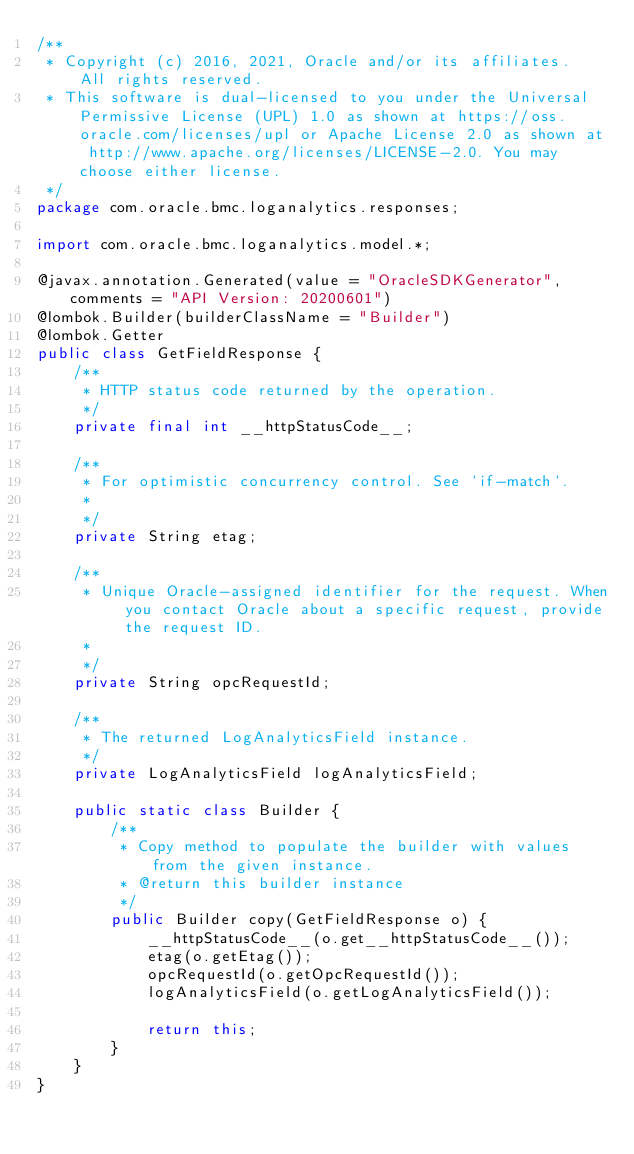Convert code to text. <code><loc_0><loc_0><loc_500><loc_500><_Java_>/**
 * Copyright (c) 2016, 2021, Oracle and/or its affiliates.  All rights reserved.
 * This software is dual-licensed to you under the Universal Permissive License (UPL) 1.0 as shown at https://oss.oracle.com/licenses/upl or Apache License 2.0 as shown at http://www.apache.org/licenses/LICENSE-2.0. You may choose either license.
 */
package com.oracle.bmc.loganalytics.responses;

import com.oracle.bmc.loganalytics.model.*;

@javax.annotation.Generated(value = "OracleSDKGenerator", comments = "API Version: 20200601")
@lombok.Builder(builderClassName = "Builder")
@lombok.Getter
public class GetFieldResponse {
    /**
     * HTTP status code returned by the operation.
     */
    private final int __httpStatusCode__;

    /**
     * For optimistic concurrency control. See `if-match`.
     *
     */
    private String etag;

    /**
     * Unique Oracle-assigned identifier for the request. When you contact Oracle about a specific request, provide the request ID.
     *
     */
    private String opcRequestId;

    /**
     * The returned LogAnalyticsField instance.
     */
    private LogAnalyticsField logAnalyticsField;

    public static class Builder {
        /**
         * Copy method to populate the builder with values from the given instance.
         * @return this builder instance
         */
        public Builder copy(GetFieldResponse o) {
            __httpStatusCode__(o.get__httpStatusCode__());
            etag(o.getEtag());
            opcRequestId(o.getOpcRequestId());
            logAnalyticsField(o.getLogAnalyticsField());

            return this;
        }
    }
}
</code> 